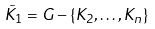Convert formula to latex. <formula><loc_0><loc_0><loc_500><loc_500>\tilde { K } _ { 1 } = G - \{ K _ { 2 } , \dots , K _ { n } \}</formula> 